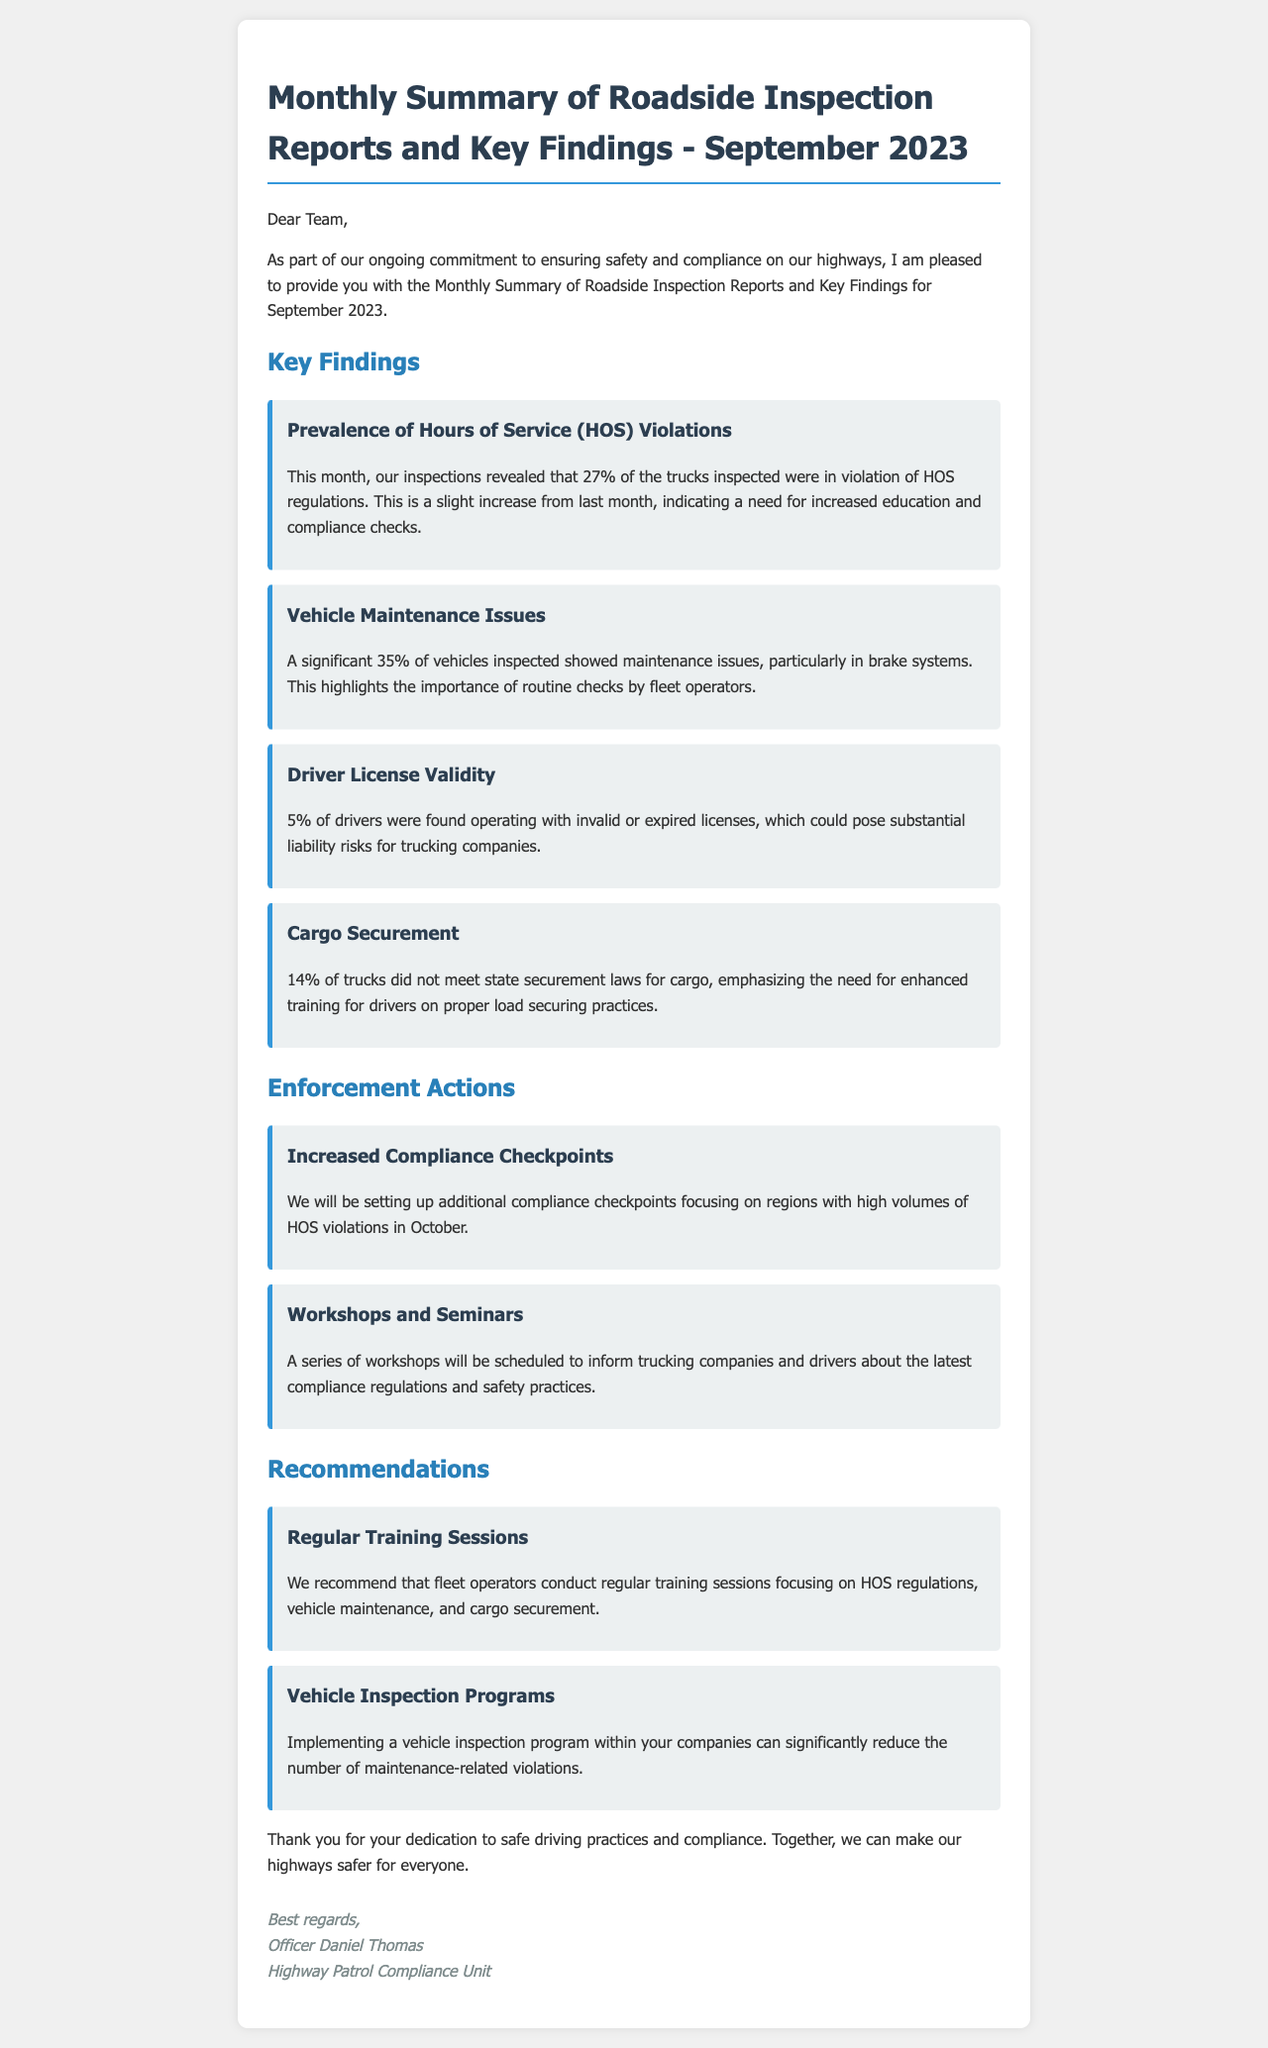what was the overall percentage of HOS violations in September? The document states that 27% of trucks inspected were in violation of HOS regulations.
Answer: 27% what percentage of vehicles had maintenance issues? According to the report, a significant 35% of vehicles inspected showed maintenance issues.
Answer: 35% how many drivers were found with invalid or expired licenses? The document mentions that 5% of drivers were operating with invalid or expired licenses.
Answer: 5% what is one enforcement action proposed for October? The document states that additional compliance checkpoints will be set up focusing on high volumes of HOS violations.
Answer: Increased Compliance Checkpoints who is the author of the email? The email is signed by Officer Daniel Thomas from the Highway Patrol Compliance Unit.
Answer: Officer Daniel Thomas why is there a need for enhanced training on cargo securement? The document notes that 14% of trucks did not meet state securement laws for cargo, highlighting the training need.
Answer: 14% what type of programs are recommended for reducing maintenance-related violations? Implementing a vehicle inspection program is recommended in the document.
Answer: Vehicle Inspection Programs what was the main purpose of the email? The email aims to provide a summary of roadside inspection reports and key findings for September 2023.
Answer: Summary of roadside inspection reports 